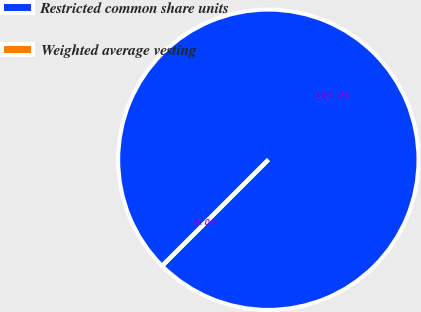<chart> <loc_0><loc_0><loc_500><loc_500><pie_chart><fcel>Restricted common share units<fcel>Weighted average vesting<nl><fcel>100.0%<fcel>0.0%<nl></chart> 